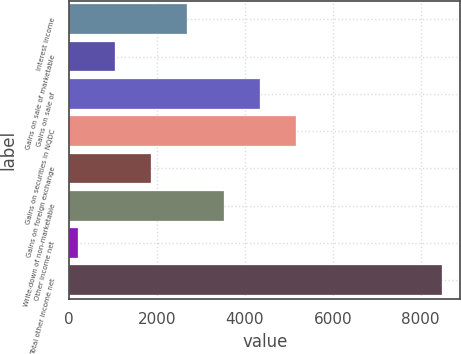Convert chart to OTSL. <chart><loc_0><loc_0><loc_500><loc_500><bar_chart><fcel>Interest income<fcel>Gains on sale of marketable<fcel>Gains on sale of<fcel>Gains on securities in NQDC<fcel>Gains on foreign exchange<fcel>Write-down of non-marketable<fcel>Other income net<fcel>Total other income net<nl><fcel>2687.2<fcel>1032.4<fcel>4342<fcel>5169.4<fcel>1859.8<fcel>3514.6<fcel>205<fcel>8479<nl></chart> 